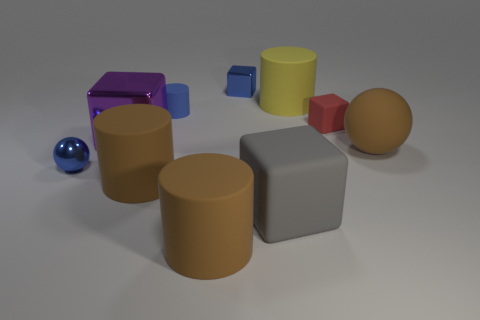What is the color of the object that is on the right side of the yellow thing and in front of the purple metallic cube?
Ensure brevity in your answer.  Brown. There is a metallic block that is behind the tiny red rubber thing; how big is it?
Your answer should be very brief. Small. How many small blue things are made of the same material as the big gray object?
Ensure brevity in your answer.  1. The tiny matte thing that is the same color as the small shiny ball is what shape?
Your response must be concise. Cylinder. Is the shape of the blue object that is on the right side of the tiny blue rubber cylinder the same as  the large metallic thing?
Offer a very short reply. Yes. There is another small block that is made of the same material as the gray cube; what is its color?
Keep it short and to the point. Red. There is a large brown object behind the sphere in front of the rubber ball; are there any big matte spheres behind it?
Your answer should be compact. No. What is the shape of the big yellow thing?
Your answer should be very brief. Cylinder. Is the number of small rubber cylinders in front of the large yellow matte thing less than the number of large purple metallic blocks?
Give a very brief answer. No. Is there another large yellow matte object that has the same shape as the yellow object?
Give a very brief answer. No. 